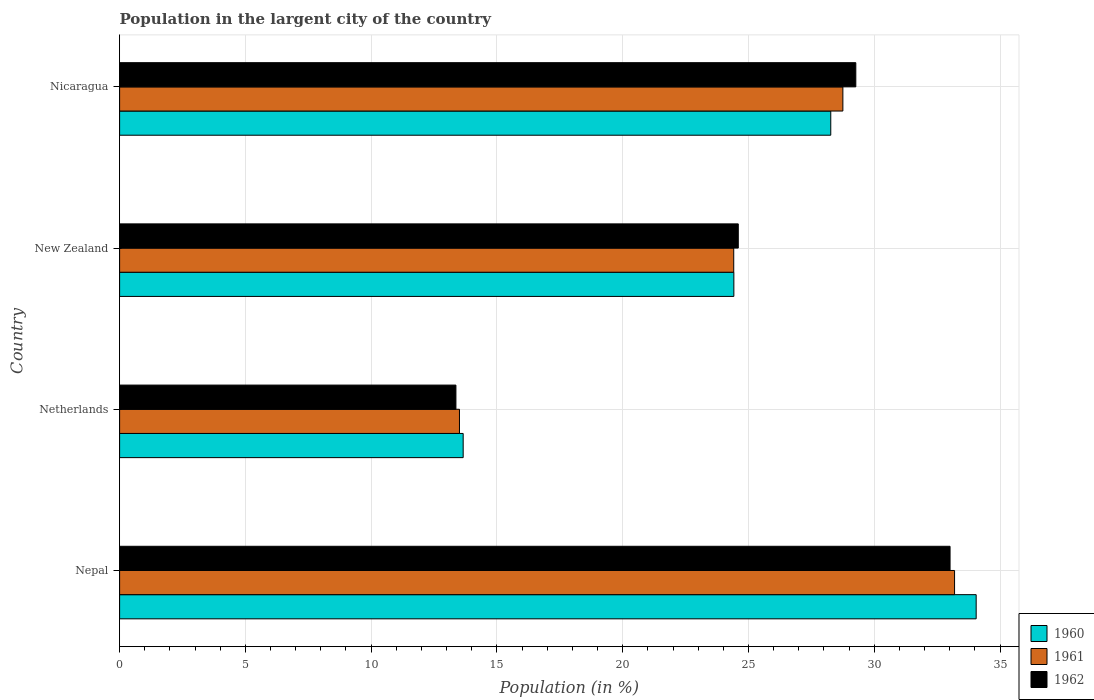How many different coloured bars are there?
Ensure brevity in your answer.  3. How many groups of bars are there?
Make the answer very short. 4. Are the number of bars on each tick of the Y-axis equal?
Your answer should be compact. Yes. How many bars are there on the 4th tick from the top?
Provide a succinct answer. 3. How many bars are there on the 1st tick from the bottom?
Keep it short and to the point. 3. What is the label of the 4th group of bars from the top?
Offer a terse response. Nepal. What is the percentage of population in the largent city in 1962 in Nicaragua?
Give a very brief answer. 29.27. Across all countries, what is the maximum percentage of population in the largent city in 1962?
Give a very brief answer. 33.01. Across all countries, what is the minimum percentage of population in the largent city in 1960?
Offer a very short reply. 13.66. In which country was the percentage of population in the largent city in 1961 maximum?
Ensure brevity in your answer.  Nepal. What is the total percentage of population in the largent city in 1961 in the graph?
Provide a succinct answer. 99.87. What is the difference between the percentage of population in the largent city in 1962 in Netherlands and that in New Zealand?
Offer a very short reply. -11.22. What is the difference between the percentage of population in the largent city in 1960 in New Zealand and the percentage of population in the largent city in 1961 in Netherlands?
Your response must be concise. 10.91. What is the average percentage of population in the largent city in 1961 per country?
Your answer should be very brief. 24.97. What is the difference between the percentage of population in the largent city in 1962 and percentage of population in the largent city in 1961 in Nepal?
Provide a succinct answer. -0.18. What is the ratio of the percentage of population in the largent city in 1962 in New Zealand to that in Nicaragua?
Provide a succinct answer. 0.84. Is the difference between the percentage of population in the largent city in 1962 in Netherlands and Nicaragua greater than the difference between the percentage of population in the largent city in 1961 in Netherlands and Nicaragua?
Your response must be concise. No. What is the difference between the highest and the second highest percentage of population in the largent city in 1962?
Ensure brevity in your answer.  3.75. What is the difference between the highest and the lowest percentage of population in the largent city in 1961?
Make the answer very short. 19.68. In how many countries, is the percentage of population in the largent city in 1961 greater than the average percentage of population in the largent city in 1961 taken over all countries?
Offer a terse response. 2. What does the 1st bar from the top in New Zealand represents?
Your answer should be compact. 1962. What does the 3rd bar from the bottom in New Zealand represents?
Keep it short and to the point. 1962. How many bars are there?
Your answer should be compact. 12. Are all the bars in the graph horizontal?
Provide a short and direct response. Yes. What is the difference between two consecutive major ticks on the X-axis?
Ensure brevity in your answer.  5. Are the values on the major ticks of X-axis written in scientific E-notation?
Keep it short and to the point. No. What is the title of the graph?
Your answer should be very brief. Population in the largent city of the country. What is the label or title of the X-axis?
Ensure brevity in your answer.  Population (in %). What is the Population (in %) of 1960 in Nepal?
Make the answer very short. 34.05. What is the Population (in %) in 1961 in Nepal?
Offer a terse response. 33.19. What is the Population (in %) in 1962 in Nepal?
Your answer should be compact. 33.01. What is the Population (in %) in 1960 in Netherlands?
Provide a succinct answer. 13.66. What is the Population (in %) of 1961 in Netherlands?
Ensure brevity in your answer.  13.51. What is the Population (in %) of 1962 in Netherlands?
Ensure brevity in your answer.  13.37. What is the Population (in %) of 1960 in New Zealand?
Make the answer very short. 24.42. What is the Population (in %) in 1961 in New Zealand?
Offer a very short reply. 24.41. What is the Population (in %) of 1962 in New Zealand?
Your answer should be compact. 24.6. What is the Population (in %) of 1960 in Nicaragua?
Keep it short and to the point. 28.27. What is the Population (in %) of 1961 in Nicaragua?
Your answer should be compact. 28.75. What is the Population (in %) of 1962 in Nicaragua?
Offer a very short reply. 29.27. Across all countries, what is the maximum Population (in %) of 1960?
Ensure brevity in your answer.  34.05. Across all countries, what is the maximum Population (in %) in 1961?
Provide a succinct answer. 33.19. Across all countries, what is the maximum Population (in %) in 1962?
Your answer should be very brief. 33.01. Across all countries, what is the minimum Population (in %) in 1960?
Provide a succinct answer. 13.66. Across all countries, what is the minimum Population (in %) of 1961?
Provide a succinct answer. 13.51. Across all countries, what is the minimum Population (in %) in 1962?
Your answer should be compact. 13.37. What is the total Population (in %) in 1960 in the graph?
Ensure brevity in your answer.  100.4. What is the total Population (in %) in 1961 in the graph?
Provide a succinct answer. 99.87. What is the total Population (in %) in 1962 in the graph?
Provide a succinct answer. 100.25. What is the difference between the Population (in %) in 1960 in Nepal and that in Netherlands?
Offer a very short reply. 20.39. What is the difference between the Population (in %) in 1961 in Nepal and that in Netherlands?
Provide a succinct answer. 19.68. What is the difference between the Population (in %) of 1962 in Nepal and that in Netherlands?
Ensure brevity in your answer.  19.64. What is the difference between the Population (in %) of 1960 in Nepal and that in New Zealand?
Give a very brief answer. 9.63. What is the difference between the Population (in %) in 1961 in Nepal and that in New Zealand?
Ensure brevity in your answer.  8.78. What is the difference between the Population (in %) in 1962 in Nepal and that in New Zealand?
Your response must be concise. 8.42. What is the difference between the Population (in %) of 1960 in Nepal and that in Nicaragua?
Ensure brevity in your answer.  5.78. What is the difference between the Population (in %) in 1961 in Nepal and that in Nicaragua?
Provide a succinct answer. 4.44. What is the difference between the Population (in %) of 1962 in Nepal and that in Nicaragua?
Give a very brief answer. 3.75. What is the difference between the Population (in %) of 1960 in Netherlands and that in New Zealand?
Ensure brevity in your answer.  -10.76. What is the difference between the Population (in %) of 1961 in Netherlands and that in New Zealand?
Offer a terse response. -10.9. What is the difference between the Population (in %) in 1962 in Netherlands and that in New Zealand?
Provide a succinct answer. -11.22. What is the difference between the Population (in %) of 1960 in Netherlands and that in Nicaragua?
Make the answer very short. -14.61. What is the difference between the Population (in %) of 1961 in Netherlands and that in Nicaragua?
Offer a very short reply. -15.24. What is the difference between the Population (in %) of 1962 in Netherlands and that in Nicaragua?
Keep it short and to the point. -15.9. What is the difference between the Population (in %) in 1960 in New Zealand and that in Nicaragua?
Your answer should be compact. -3.85. What is the difference between the Population (in %) of 1961 in New Zealand and that in Nicaragua?
Offer a very short reply. -4.34. What is the difference between the Population (in %) of 1962 in New Zealand and that in Nicaragua?
Give a very brief answer. -4.67. What is the difference between the Population (in %) of 1960 in Nepal and the Population (in %) of 1961 in Netherlands?
Provide a short and direct response. 20.54. What is the difference between the Population (in %) in 1960 in Nepal and the Population (in %) in 1962 in Netherlands?
Make the answer very short. 20.68. What is the difference between the Population (in %) in 1961 in Nepal and the Population (in %) in 1962 in Netherlands?
Provide a succinct answer. 19.82. What is the difference between the Population (in %) in 1960 in Nepal and the Population (in %) in 1961 in New Zealand?
Offer a terse response. 9.64. What is the difference between the Population (in %) of 1960 in Nepal and the Population (in %) of 1962 in New Zealand?
Offer a terse response. 9.46. What is the difference between the Population (in %) in 1961 in Nepal and the Population (in %) in 1962 in New Zealand?
Make the answer very short. 8.6. What is the difference between the Population (in %) in 1960 in Nepal and the Population (in %) in 1961 in Nicaragua?
Give a very brief answer. 5.3. What is the difference between the Population (in %) of 1960 in Nepal and the Population (in %) of 1962 in Nicaragua?
Your answer should be compact. 4.78. What is the difference between the Population (in %) in 1961 in Nepal and the Population (in %) in 1962 in Nicaragua?
Offer a very short reply. 3.93. What is the difference between the Population (in %) of 1960 in Netherlands and the Population (in %) of 1961 in New Zealand?
Give a very brief answer. -10.76. What is the difference between the Population (in %) in 1960 in Netherlands and the Population (in %) in 1962 in New Zealand?
Provide a short and direct response. -10.94. What is the difference between the Population (in %) of 1961 in Netherlands and the Population (in %) of 1962 in New Zealand?
Keep it short and to the point. -11.08. What is the difference between the Population (in %) in 1960 in Netherlands and the Population (in %) in 1961 in Nicaragua?
Give a very brief answer. -15.1. What is the difference between the Population (in %) of 1960 in Netherlands and the Population (in %) of 1962 in Nicaragua?
Offer a very short reply. -15.61. What is the difference between the Population (in %) in 1961 in Netherlands and the Population (in %) in 1962 in Nicaragua?
Offer a very short reply. -15.76. What is the difference between the Population (in %) of 1960 in New Zealand and the Population (in %) of 1961 in Nicaragua?
Your answer should be compact. -4.33. What is the difference between the Population (in %) in 1960 in New Zealand and the Population (in %) in 1962 in Nicaragua?
Offer a very short reply. -4.85. What is the difference between the Population (in %) in 1961 in New Zealand and the Population (in %) in 1962 in Nicaragua?
Your response must be concise. -4.85. What is the average Population (in %) of 1960 per country?
Your response must be concise. 25.1. What is the average Population (in %) in 1961 per country?
Your answer should be very brief. 24.97. What is the average Population (in %) in 1962 per country?
Your response must be concise. 25.06. What is the difference between the Population (in %) in 1960 and Population (in %) in 1961 in Nepal?
Your response must be concise. 0.86. What is the difference between the Population (in %) in 1960 and Population (in %) in 1962 in Nepal?
Make the answer very short. 1.04. What is the difference between the Population (in %) in 1961 and Population (in %) in 1962 in Nepal?
Provide a short and direct response. 0.18. What is the difference between the Population (in %) in 1960 and Population (in %) in 1961 in Netherlands?
Offer a very short reply. 0.15. What is the difference between the Population (in %) in 1960 and Population (in %) in 1962 in Netherlands?
Give a very brief answer. 0.29. What is the difference between the Population (in %) in 1961 and Population (in %) in 1962 in Netherlands?
Offer a terse response. 0.14. What is the difference between the Population (in %) in 1960 and Population (in %) in 1961 in New Zealand?
Keep it short and to the point. 0. What is the difference between the Population (in %) in 1960 and Population (in %) in 1962 in New Zealand?
Your answer should be very brief. -0.18. What is the difference between the Population (in %) in 1961 and Population (in %) in 1962 in New Zealand?
Offer a terse response. -0.18. What is the difference between the Population (in %) of 1960 and Population (in %) of 1961 in Nicaragua?
Offer a very short reply. -0.48. What is the difference between the Population (in %) in 1960 and Population (in %) in 1962 in Nicaragua?
Your response must be concise. -1. What is the difference between the Population (in %) in 1961 and Population (in %) in 1962 in Nicaragua?
Give a very brief answer. -0.51. What is the ratio of the Population (in %) in 1960 in Nepal to that in Netherlands?
Make the answer very short. 2.49. What is the ratio of the Population (in %) in 1961 in Nepal to that in Netherlands?
Offer a terse response. 2.46. What is the ratio of the Population (in %) of 1962 in Nepal to that in Netherlands?
Give a very brief answer. 2.47. What is the ratio of the Population (in %) in 1960 in Nepal to that in New Zealand?
Your response must be concise. 1.39. What is the ratio of the Population (in %) of 1961 in Nepal to that in New Zealand?
Your response must be concise. 1.36. What is the ratio of the Population (in %) of 1962 in Nepal to that in New Zealand?
Offer a terse response. 1.34. What is the ratio of the Population (in %) of 1960 in Nepal to that in Nicaragua?
Offer a very short reply. 1.2. What is the ratio of the Population (in %) of 1961 in Nepal to that in Nicaragua?
Keep it short and to the point. 1.15. What is the ratio of the Population (in %) in 1962 in Nepal to that in Nicaragua?
Your response must be concise. 1.13. What is the ratio of the Population (in %) of 1960 in Netherlands to that in New Zealand?
Keep it short and to the point. 0.56. What is the ratio of the Population (in %) in 1961 in Netherlands to that in New Zealand?
Offer a terse response. 0.55. What is the ratio of the Population (in %) in 1962 in Netherlands to that in New Zealand?
Ensure brevity in your answer.  0.54. What is the ratio of the Population (in %) of 1960 in Netherlands to that in Nicaragua?
Provide a succinct answer. 0.48. What is the ratio of the Population (in %) of 1961 in Netherlands to that in Nicaragua?
Your response must be concise. 0.47. What is the ratio of the Population (in %) in 1962 in Netherlands to that in Nicaragua?
Provide a succinct answer. 0.46. What is the ratio of the Population (in %) in 1960 in New Zealand to that in Nicaragua?
Your answer should be very brief. 0.86. What is the ratio of the Population (in %) of 1961 in New Zealand to that in Nicaragua?
Offer a very short reply. 0.85. What is the ratio of the Population (in %) of 1962 in New Zealand to that in Nicaragua?
Keep it short and to the point. 0.84. What is the difference between the highest and the second highest Population (in %) in 1960?
Your response must be concise. 5.78. What is the difference between the highest and the second highest Population (in %) of 1961?
Your answer should be very brief. 4.44. What is the difference between the highest and the second highest Population (in %) of 1962?
Your answer should be very brief. 3.75. What is the difference between the highest and the lowest Population (in %) of 1960?
Give a very brief answer. 20.39. What is the difference between the highest and the lowest Population (in %) in 1961?
Your answer should be compact. 19.68. What is the difference between the highest and the lowest Population (in %) of 1962?
Your answer should be compact. 19.64. 